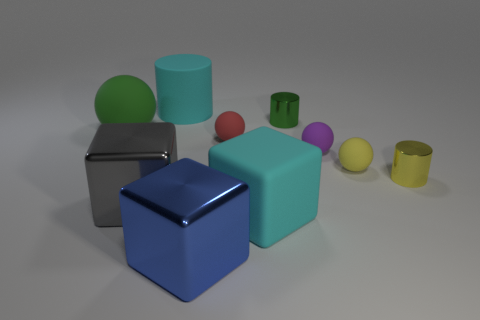What is the color of the large sphere that is the same material as the red object?
Your answer should be very brief. Green. How many gray metallic blocks are the same size as the blue thing?
Ensure brevity in your answer.  1. What is the purple ball made of?
Your answer should be very brief. Rubber. Are there more small metallic cylinders than yellow rubber things?
Provide a succinct answer. Yes. Does the blue thing have the same shape as the big gray object?
Provide a succinct answer. Yes. There is a rubber thing behind the green cylinder; is its color the same as the big rubber object to the right of the big matte cylinder?
Your answer should be very brief. Yes. Are there fewer spheres that are to the left of the small purple matte ball than small red spheres in front of the tiny red ball?
Give a very brief answer. No. There is a large cyan matte object in front of the tiny yellow rubber sphere; what shape is it?
Your answer should be very brief. Cube. There is a thing that is the same color as the big matte sphere; what is it made of?
Offer a terse response. Metal. How many other objects are the same material as the yellow cylinder?
Provide a succinct answer. 3. 